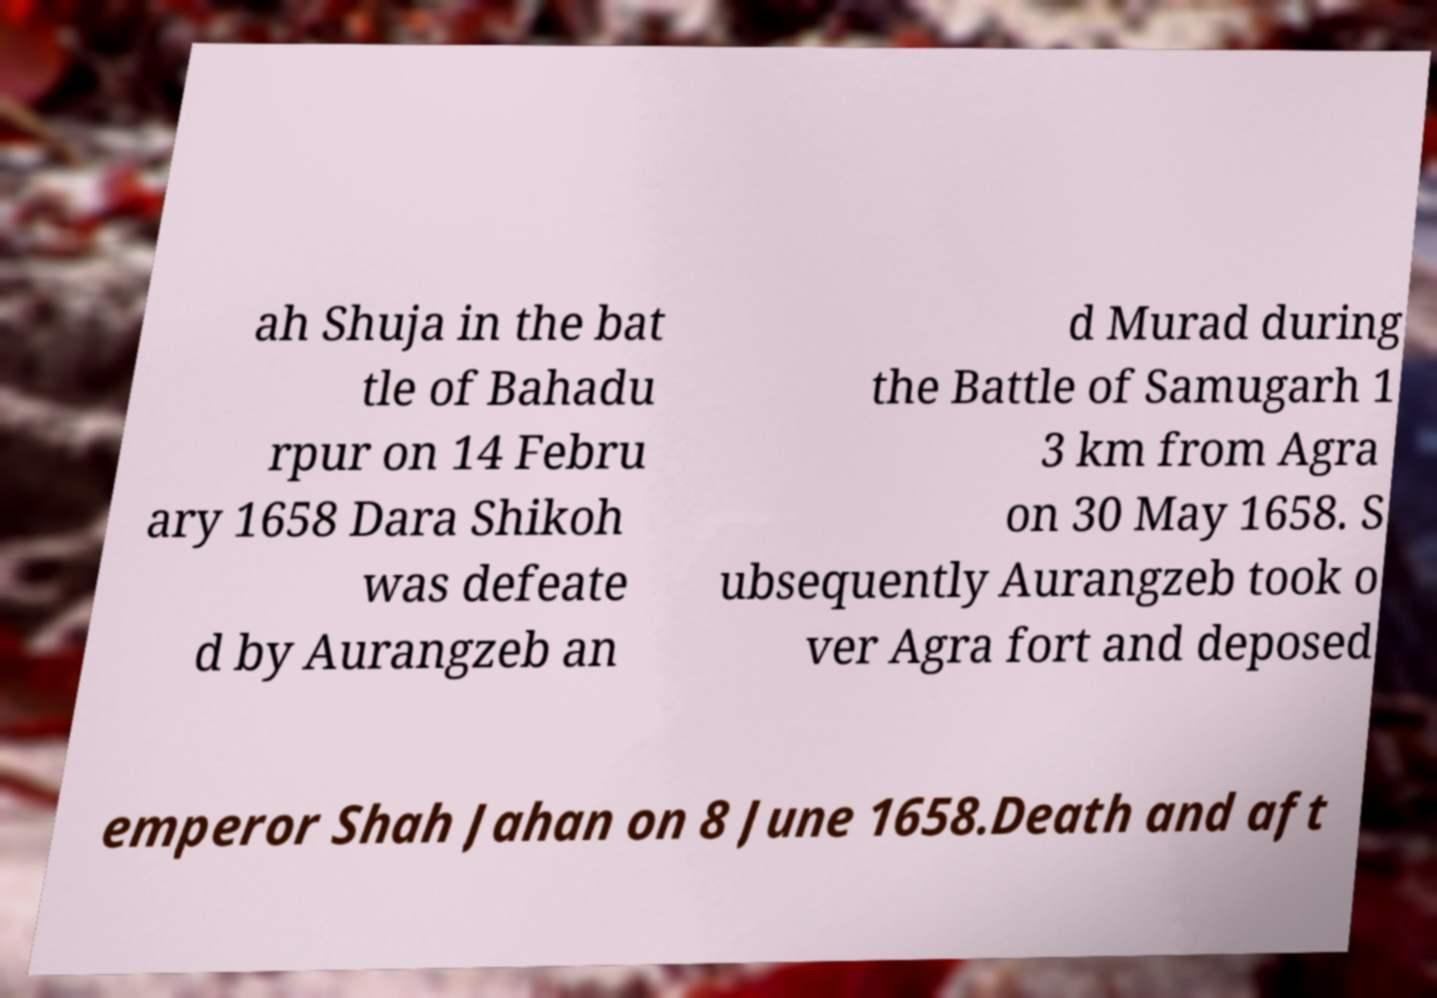What messages or text are displayed in this image? I need them in a readable, typed format. ah Shuja in the bat tle of Bahadu rpur on 14 Febru ary 1658 Dara Shikoh was defeate d by Aurangzeb an d Murad during the Battle of Samugarh 1 3 km from Agra on 30 May 1658. S ubsequently Aurangzeb took o ver Agra fort and deposed emperor Shah Jahan on 8 June 1658.Death and aft 